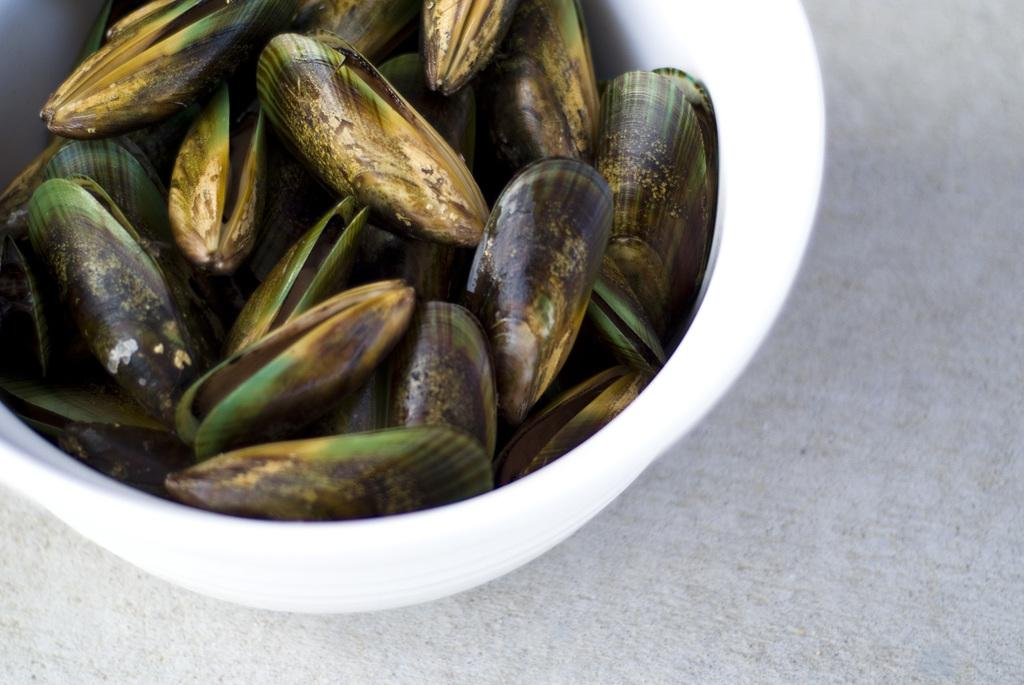What is the main object in the image? There is a bowl in the image. What is inside the bowl? The bowl contains a group of objects. Where is the bowl located? The bowl is placed on a platform. What type of window can be seen in the image? There is no window present in the image; it only features a bowl with objects on a platform. 